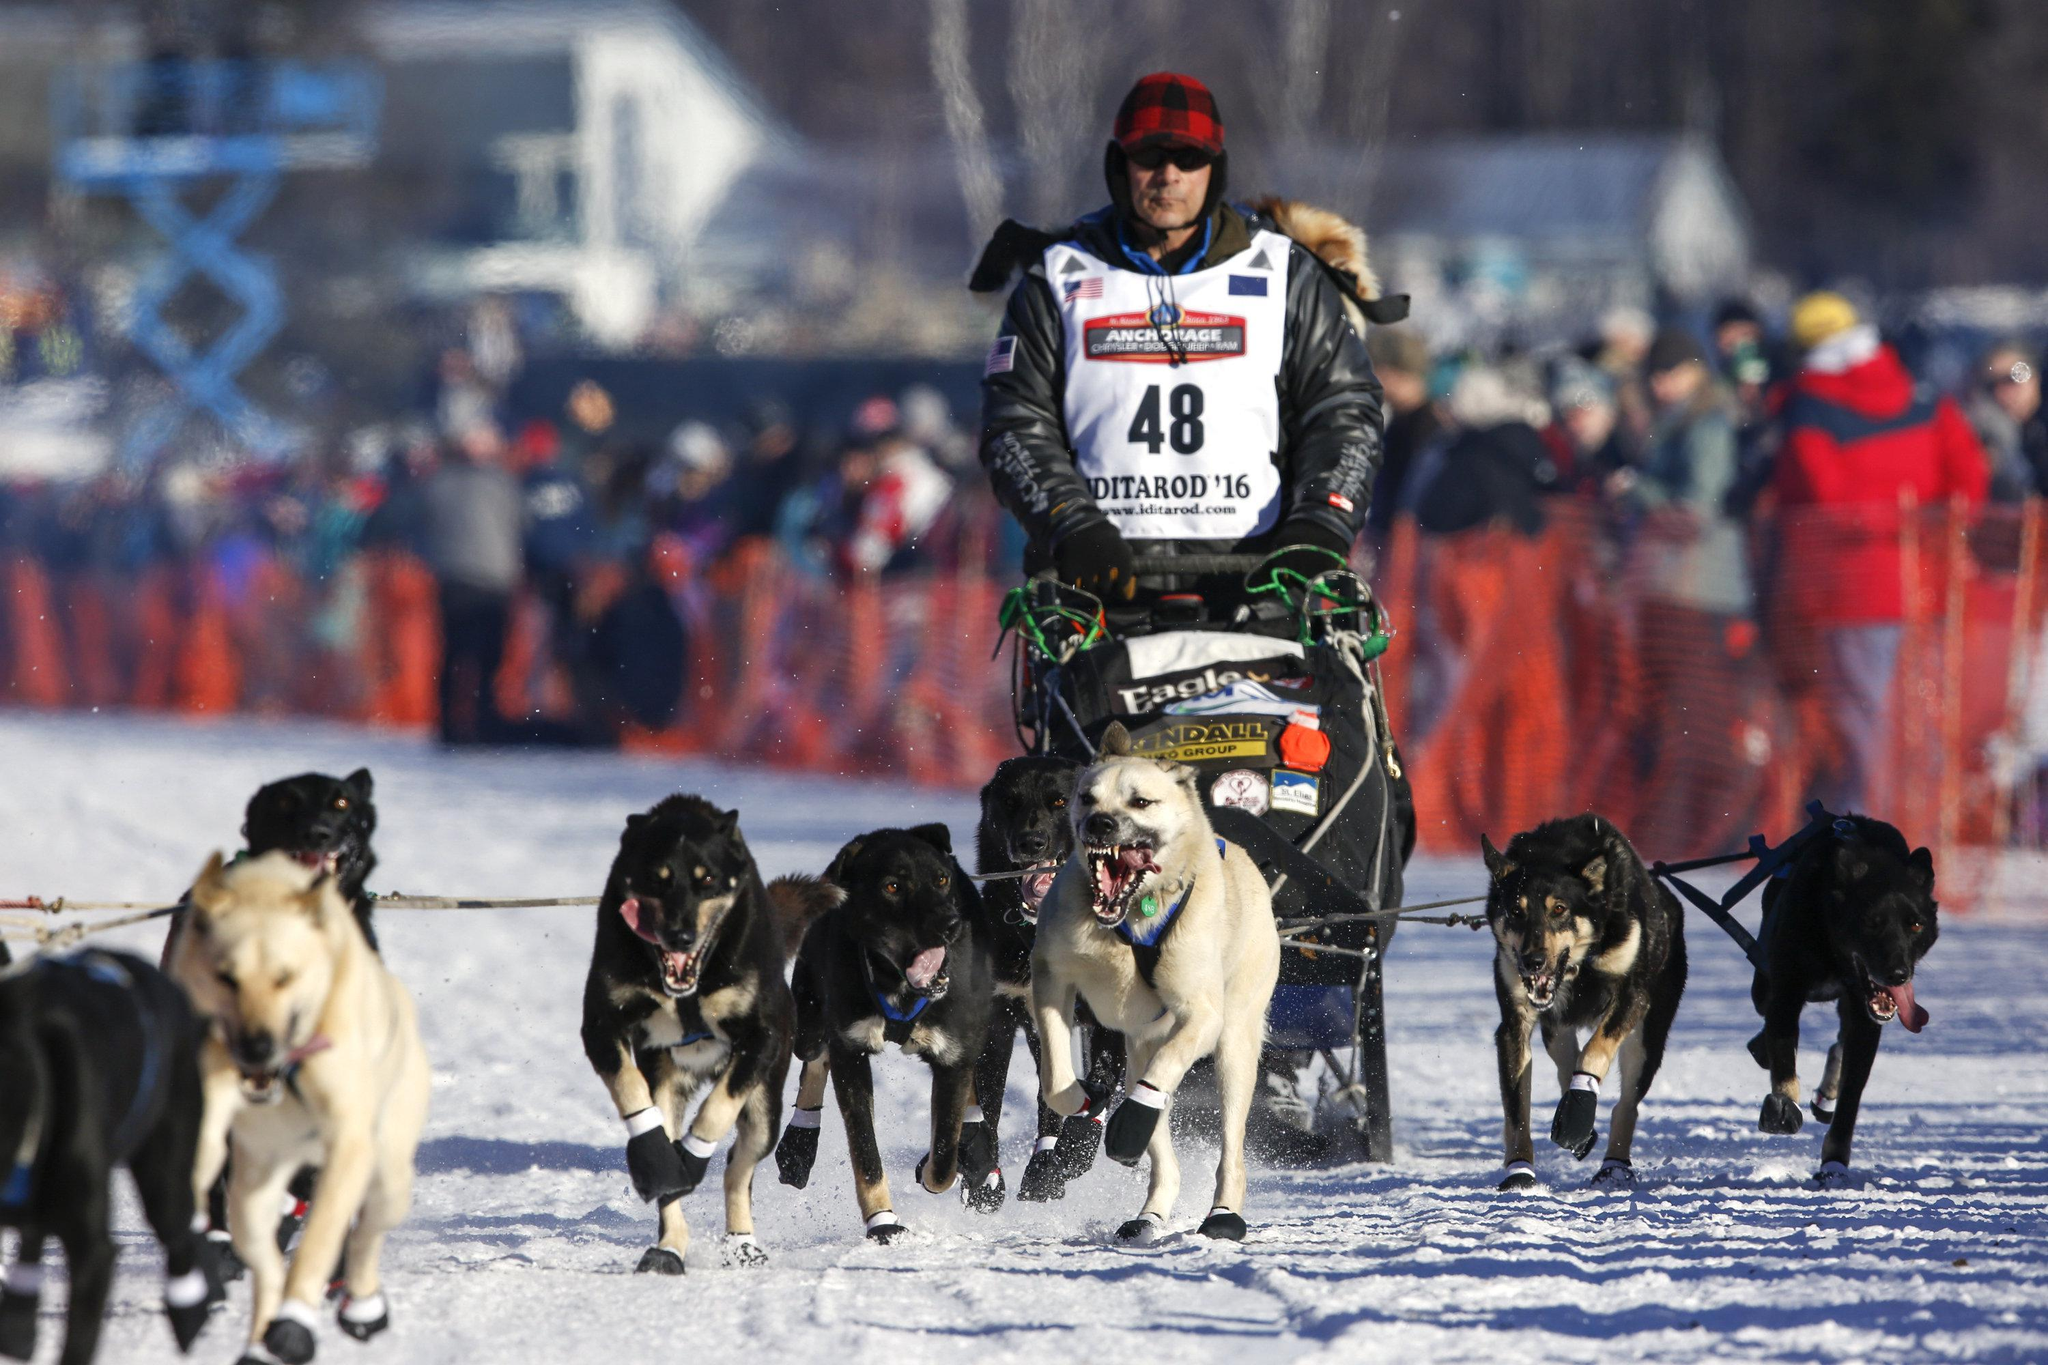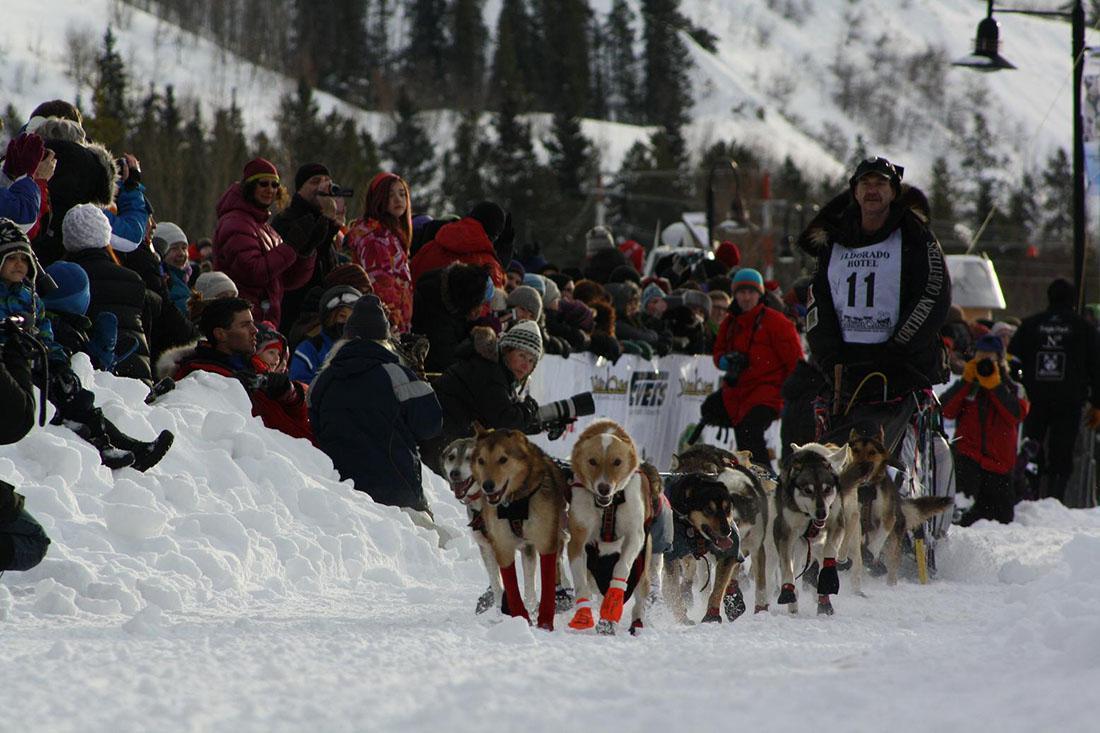The first image is the image on the left, the second image is the image on the right. Examine the images to the left and right. Is the description "An image shows one dog team moving diagonally across the snow, with snow-covered evergreens in the background and no bystanders." accurate? Answer yes or no. No. The first image is the image on the left, the second image is the image on the right. Analyze the images presented: Is the assertion "Someone is wearing a vest with a number in at least one of the images." valid? Answer yes or no. Yes. 